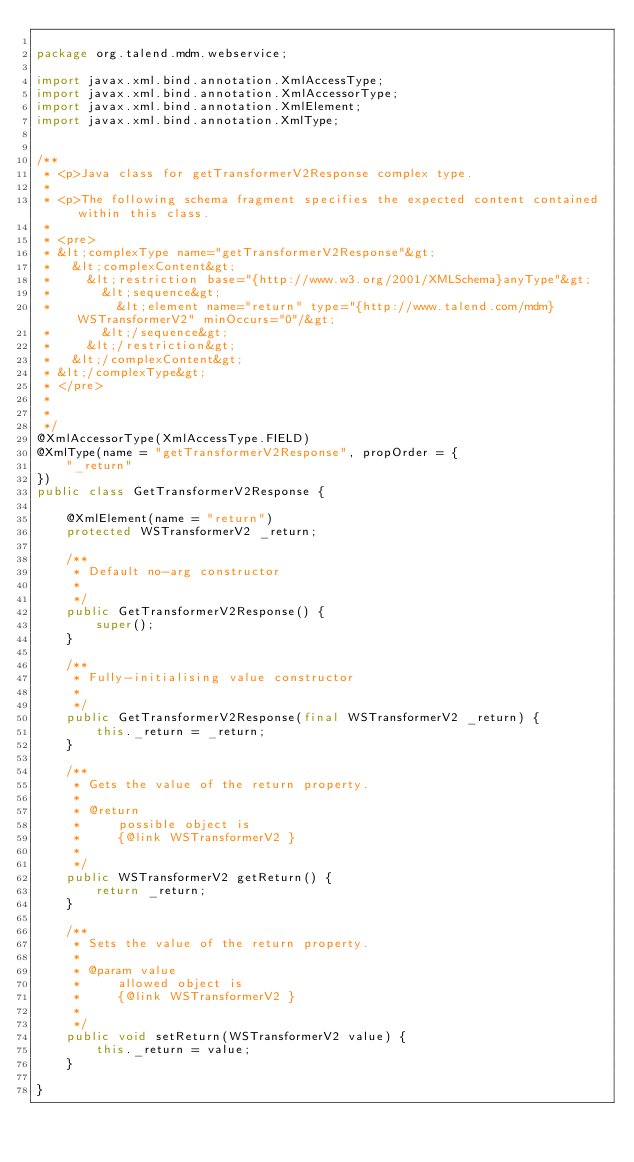<code> <loc_0><loc_0><loc_500><loc_500><_Java_>
package org.talend.mdm.webservice;

import javax.xml.bind.annotation.XmlAccessType;
import javax.xml.bind.annotation.XmlAccessorType;
import javax.xml.bind.annotation.XmlElement;
import javax.xml.bind.annotation.XmlType;


/**
 * <p>Java class for getTransformerV2Response complex type.
 * 
 * <p>The following schema fragment specifies the expected content contained within this class.
 * 
 * <pre>
 * &lt;complexType name="getTransformerV2Response"&gt;
 *   &lt;complexContent&gt;
 *     &lt;restriction base="{http://www.w3.org/2001/XMLSchema}anyType"&gt;
 *       &lt;sequence&gt;
 *         &lt;element name="return" type="{http://www.talend.com/mdm}WSTransformerV2" minOccurs="0"/&gt;
 *       &lt;/sequence&gt;
 *     &lt;/restriction&gt;
 *   &lt;/complexContent&gt;
 * &lt;/complexType&gt;
 * </pre>
 * 
 * 
 */
@XmlAccessorType(XmlAccessType.FIELD)
@XmlType(name = "getTransformerV2Response", propOrder = {
    "_return"
})
public class GetTransformerV2Response {

    @XmlElement(name = "return")
    protected WSTransformerV2 _return;

    /**
     * Default no-arg constructor
     * 
     */
    public GetTransformerV2Response() {
        super();
    }

    /**
     * Fully-initialising value constructor
     * 
     */
    public GetTransformerV2Response(final WSTransformerV2 _return) {
        this._return = _return;
    }

    /**
     * Gets the value of the return property.
     * 
     * @return
     *     possible object is
     *     {@link WSTransformerV2 }
     *     
     */
    public WSTransformerV2 getReturn() {
        return _return;
    }

    /**
     * Sets the value of the return property.
     * 
     * @param value
     *     allowed object is
     *     {@link WSTransformerV2 }
     *     
     */
    public void setReturn(WSTransformerV2 value) {
        this._return = value;
    }

}
</code> 